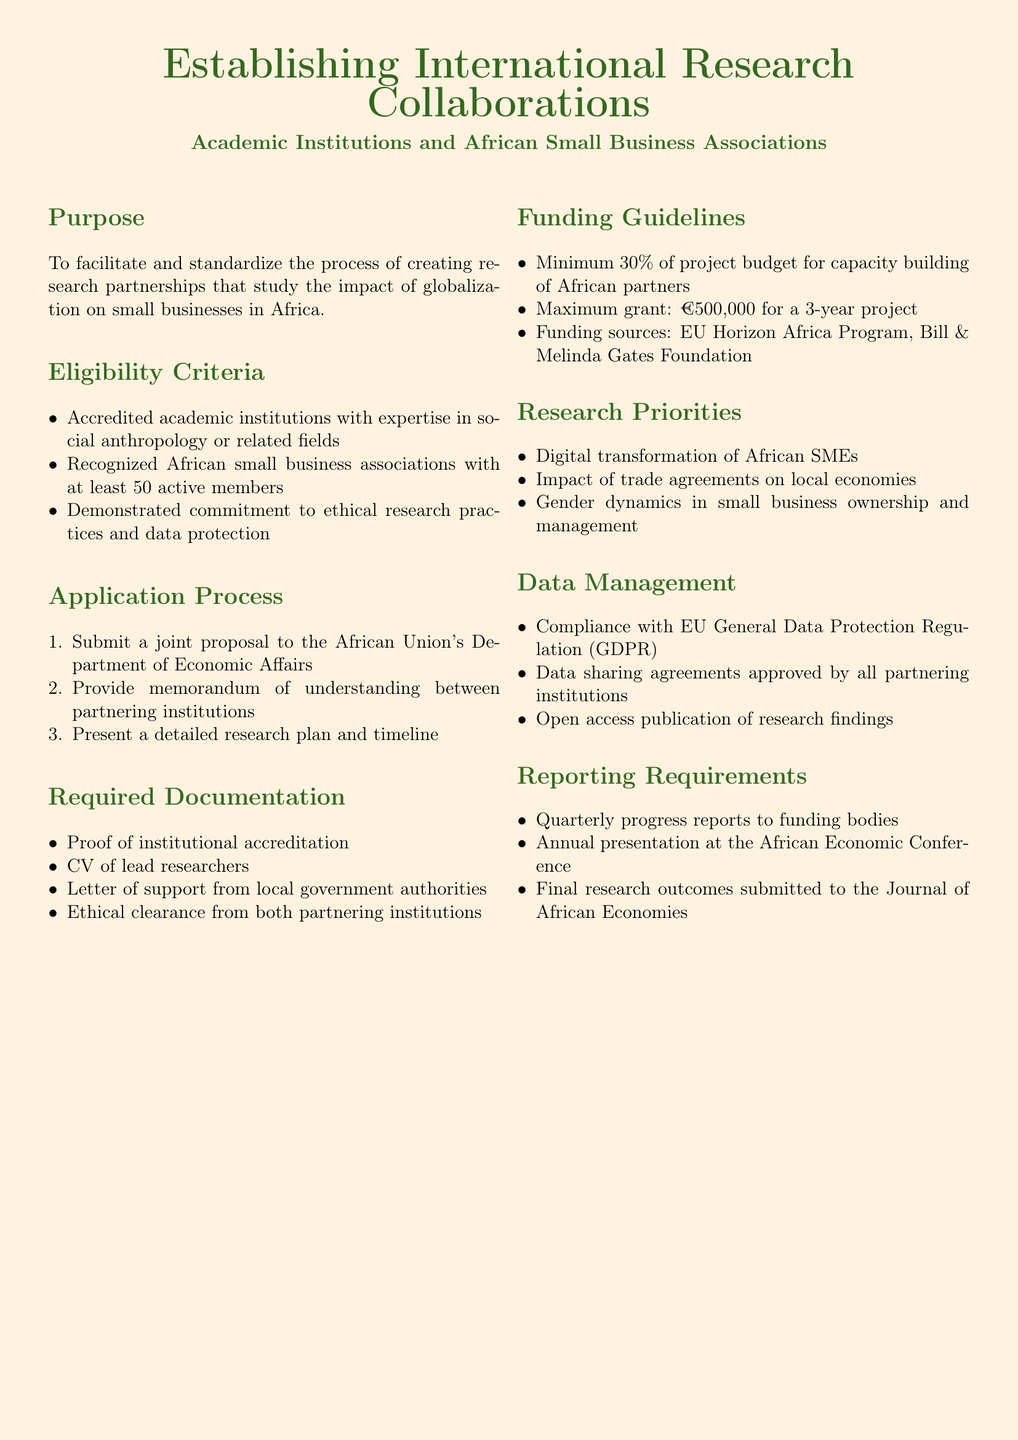What is the purpose of the document? The purpose outlines the aim of creating research partnerships that study the impact of globalization on small businesses in Africa.
Answer: To facilitate and standardize the process of creating research partnerships that study the impact of globalization on small businesses in Africa Who is eligible to apply? The eligibility criteria specify what institutions can apply, which are academic institutions and recognized African small business associations.
Answer: Accredited academic institutions and recognized African small business associations What is the maximum grant amount? The funding guidelines mention the maximum grant amount available for projects as stated in the document.
Answer: €500,000 What percentage of the budget must be allocated to capacity building? The funding guidelines detail the minimum percentage of the project budget that should be dedicated to capacity building for African partners.
Answer: 30% What is one of the research priorities? The research priorities section lists various topics, and one can be provided as an example.
Answer: Digital transformation of African SMEs What is required for ethical clearance? The required documentation includes a clause regarding ethical practices needed from both partnering institutions.
Answer: Ethical clearance from both partnering institutions How often must progress reports be submitted? The reporting requirements section specifies the frequency of required progress reports to funding bodies.
Answer: Quarterly What type of publication is required for research findings? The data management section indicates how the research findings should be made available to the public.
Answer: Open access publication of research findings 